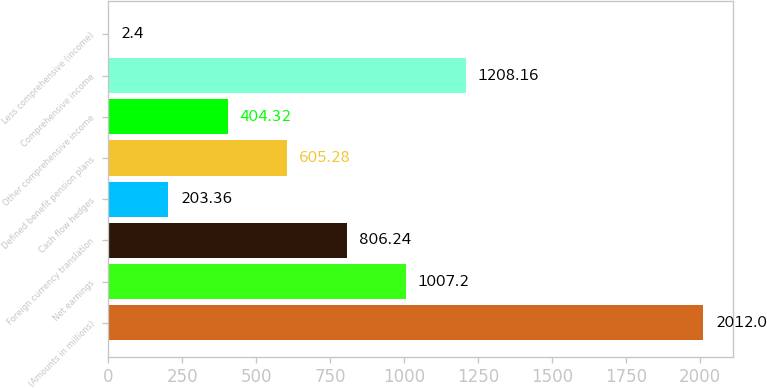<chart> <loc_0><loc_0><loc_500><loc_500><bar_chart><fcel>(Amounts in millions)<fcel>Net earnings<fcel>Foreign currency translation<fcel>Cash flow hedges<fcel>Defined benefit pension plans<fcel>Other comprehensive income<fcel>Comprehensive income<fcel>Less comprehensive (income)<nl><fcel>2012<fcel>1007.2<fcel>806.24<fcel>203.36<fcel>605.28<fcel>404.32<fcel>1208.16<fcel>2.4<nl></chart> 